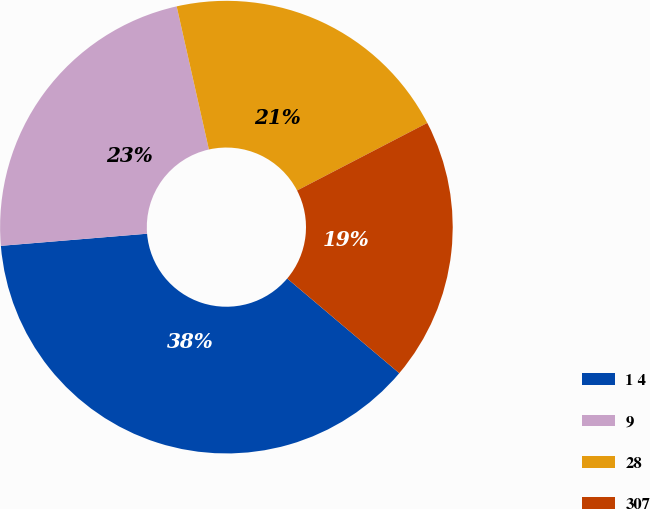Convert chart to OTSL. <chart><loc_0><loc_0><loc_500><loc_500><pie_chart><fcel>1 4<fcel>9<fcel>28<fcel>307<nl><fcel>37.52%<fcel>22.79%<fcel>20.91%<fcel>18.78%<nl></chart> 